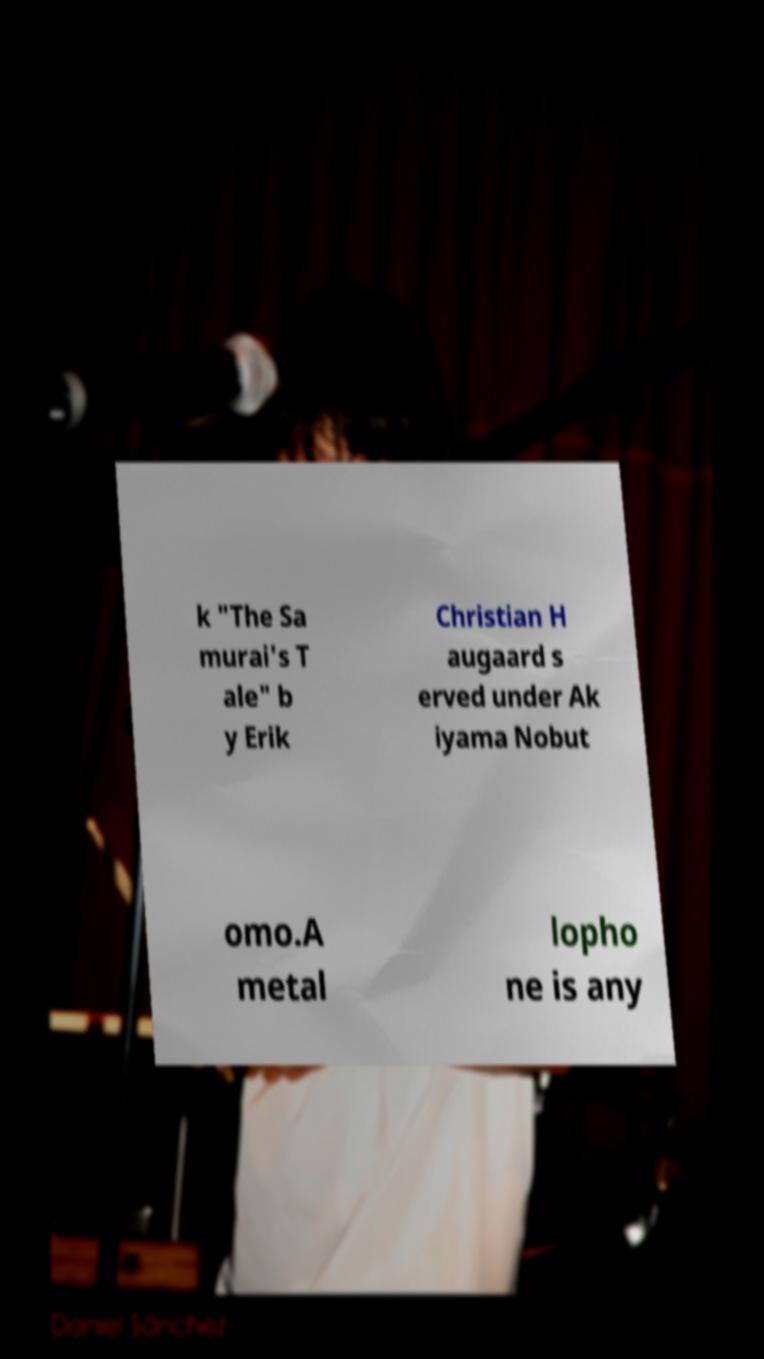I need the written content from this picture converted into text. Can you do that? k "The Sa murai's T ale" b y Erik Christian H augaard s erved under Ak iyama Nobut omo.A metal lopho ne is any 